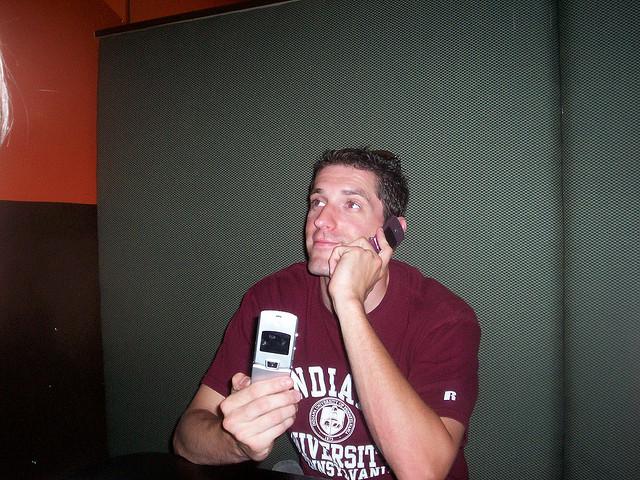Is the man looking at the camera?
Be succinct. No. What university does this man support?
Write a very short answer. Indiana. Why does he have two phones?
Answer briefly. Business. Are the boys taking a phone call?
Short answer required. Yes. What is the color of the wall?
Give a very brief answer. Gray. 